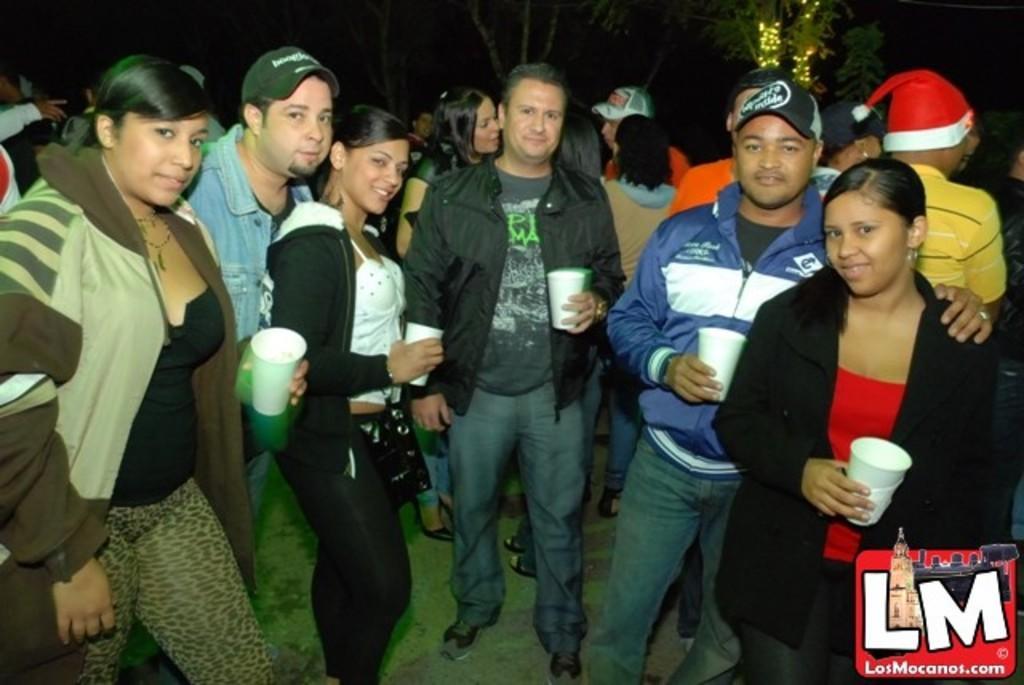How would you summarize this image in a sentence or two? There are many people. Some are wearing caps and holding cups. In the background there are trees and lights. In the right bottom corner there is a watermark. 